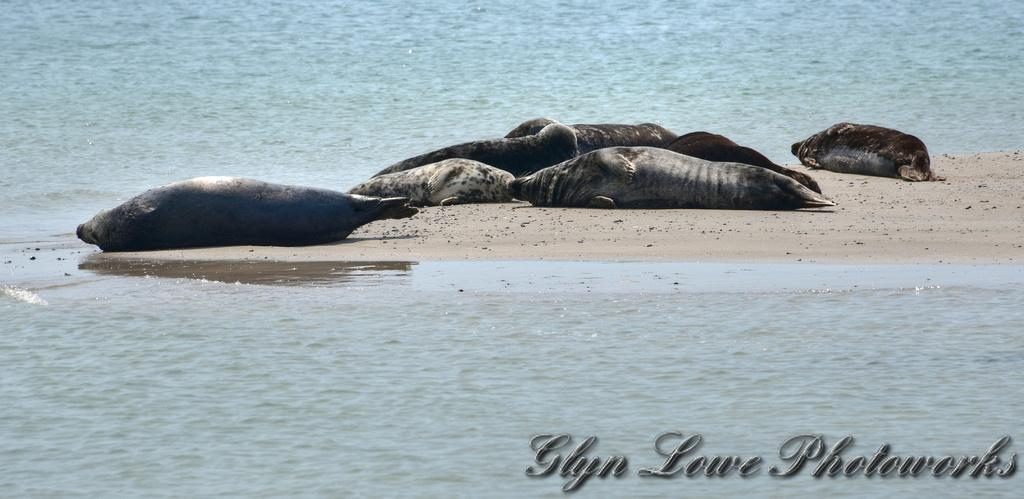What animals can be seen in the image? There are seals lying on the sand in the image. What type of environment is depicted in the image? The image shows a beach, as there is sand and water visible. Is there any text or logo present in the image? Yes, there is a watermark in the right corner of the image. How many balls are being juggled by the seals in the image? There are no balls present in the image; the seals are lying on the sand. What type of string is attached to the seals in the image? There is no string attached to the seals in the image; they are simply lying on the sand. 